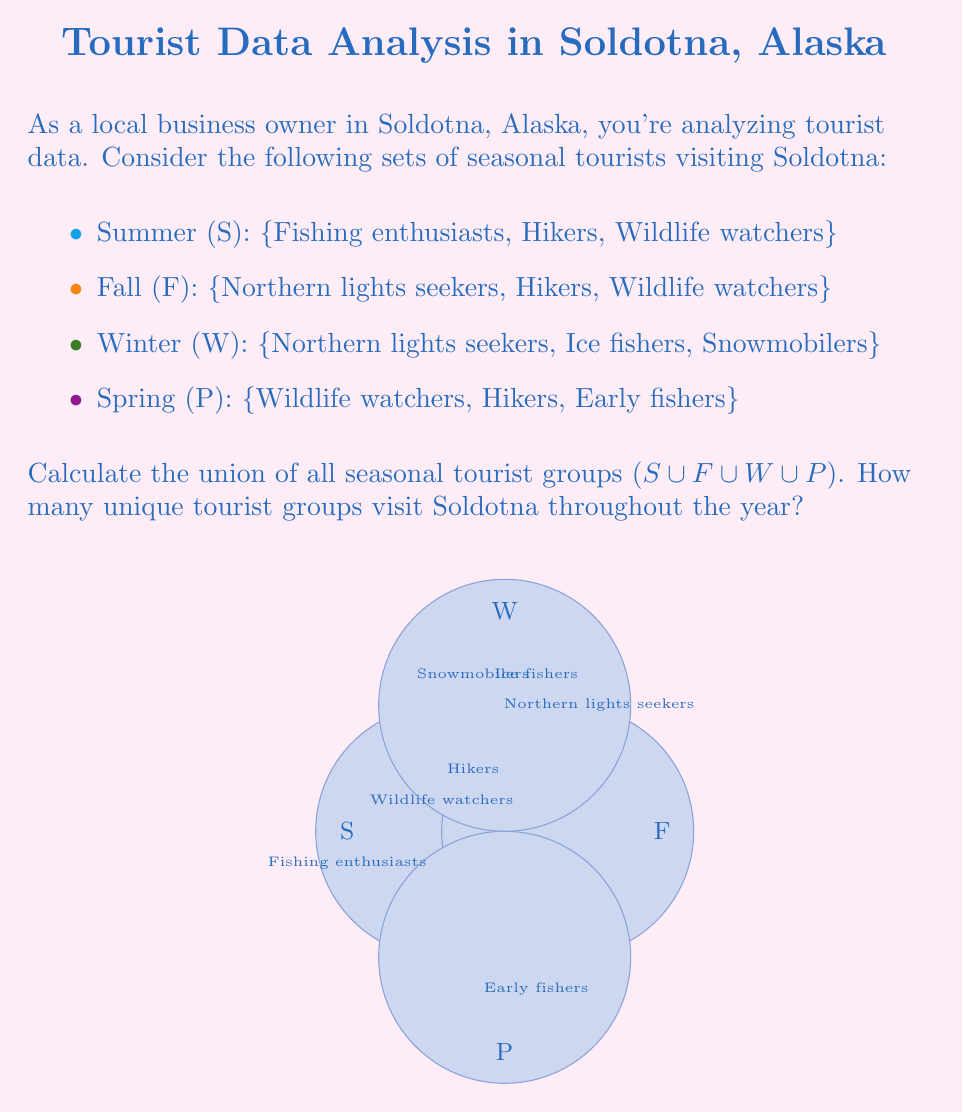Can you answer this question? To solve this problem, we need to find the union of all four sets. Let's approach this step-by-step:

1) First, let's list out all the elements in each set:
   S = {Fishing enthusiasts, Hikers, Wildlife watchers}
   F = {Northern lights seekers, Hikers, Wildlife watchers}
   W = {Northern lights seekers, Ice fishers, Snowmobilers}
   P = {Wildlife watchers, Hikers, Early fishers}

2) The union of these sets will include all unique elements that appear in at least one of the sets. Let's combine them:

   S ∪ F ∪ W ∪ P = {Fishing enthusiasts, Hikers, Wildlife watchers, Northern lights seekers, Ice fishers, Snowmobilers, Early fishers}

3) Now, let's count the unique elements:
   1. Fishing enthusiasts
   2. Hikers
   3. Wildlife watchers
   4. Northern lights seekers
   5. Ice fishers
   6. Snowmobilers
   7. Early fishers

Therefore, there are 7 unique tourist groups that visit Soldotna throughout the year.

Mathematically, we can express this as:
$$|S \cup F \cup W \cup P| = 7$$

Where $|...|$ denotes the cardinality (number of elements) of the set.
Answer: 7 unique tourist groups 